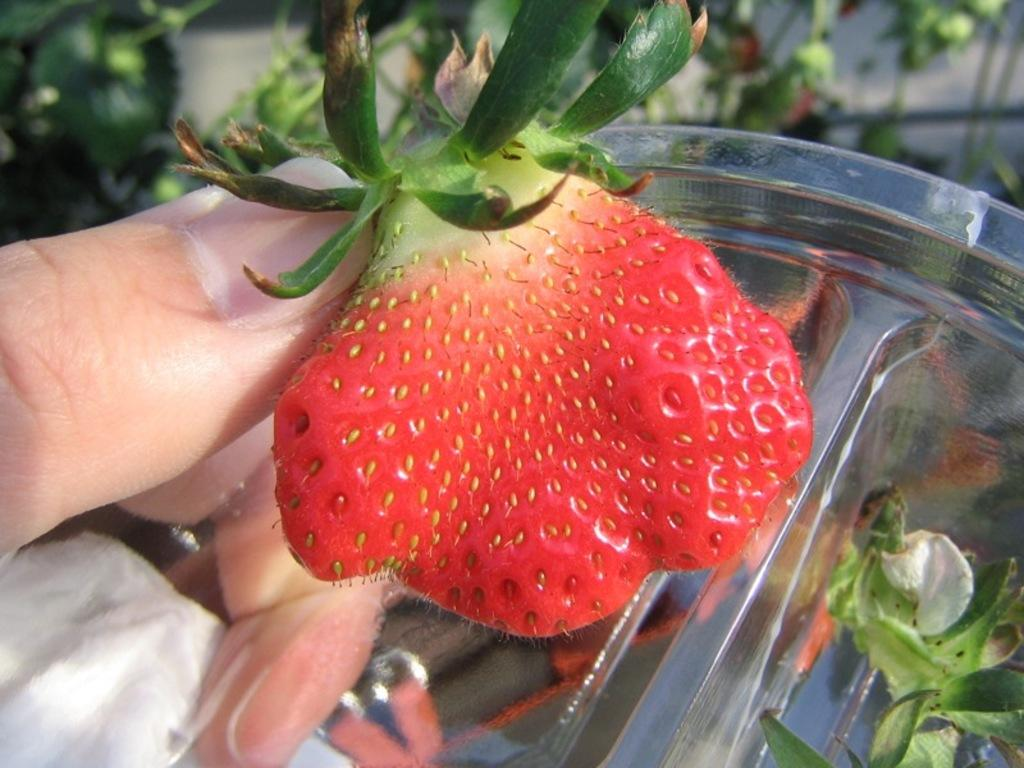What type of food is present in the image? There is a fruit in the image. What can be seen on the left side of the image? There are fingers on the left side of the image. What is located on the right side of the image? There is a bowl on the right side of the image. What type of grip can be seen on the station in the image? There is no grip or station present in the image. How does the fruit enhance the hearing experience in the image? The fruit does not affect the hearing experience in the image; it is a visual element. 